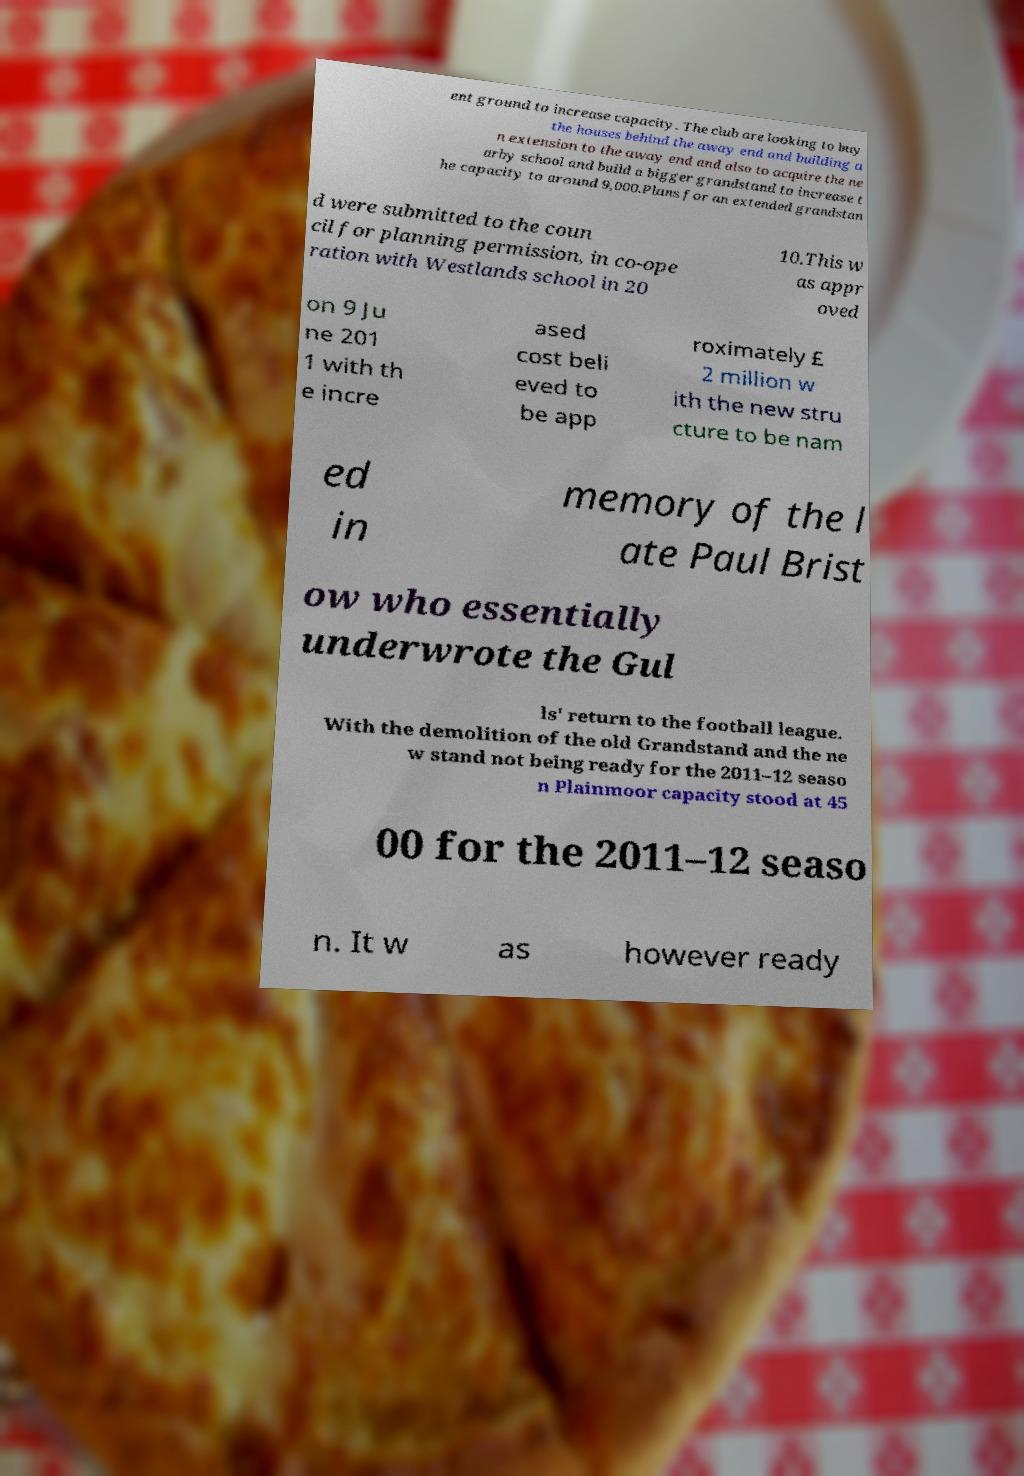I need the written content from this picture converted into text. Can you do that? ent ground to increase capacity. The club are looking to buy the houses behind the away end and building a n extension to the away end and also to acquire the ne arby school and build a bigger grandstand to increase t he capacity to around 9,000.Plans for an extended grandstan d were submitted to the coun cil for planning permission, in co-ope ration with Westlands school in 20 10.This w as appr oved on 9 Ju ne 201 1 with th e incre ased cost beli eved to be app roximately £ 2 million w ith the new stru cture to be nam ed in memory of the l ate Paul Brist ow who essentially underwrote the Gul ls' return to the football league. With the demolition of the old Grandstand and the ne w stand not being ready for the 2011–12 seaso n Plainmoor capacity stood at 45 00 for the 2011–12 seaso n. It w as however ready 